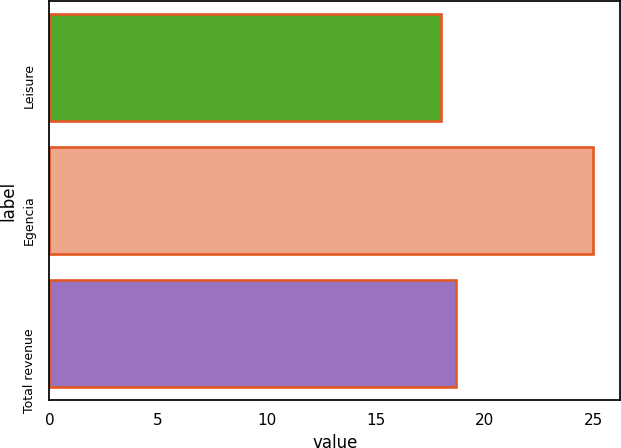Convert chart to OTSL. <chart><loc_0><loc_0><loc_500><loc_500><bar_chart><fcel>Leisure<fcel>Egencia<fcel>Total revenue<nl><fcel>18<fcel>25<fcel>18.7<nl></chart> 